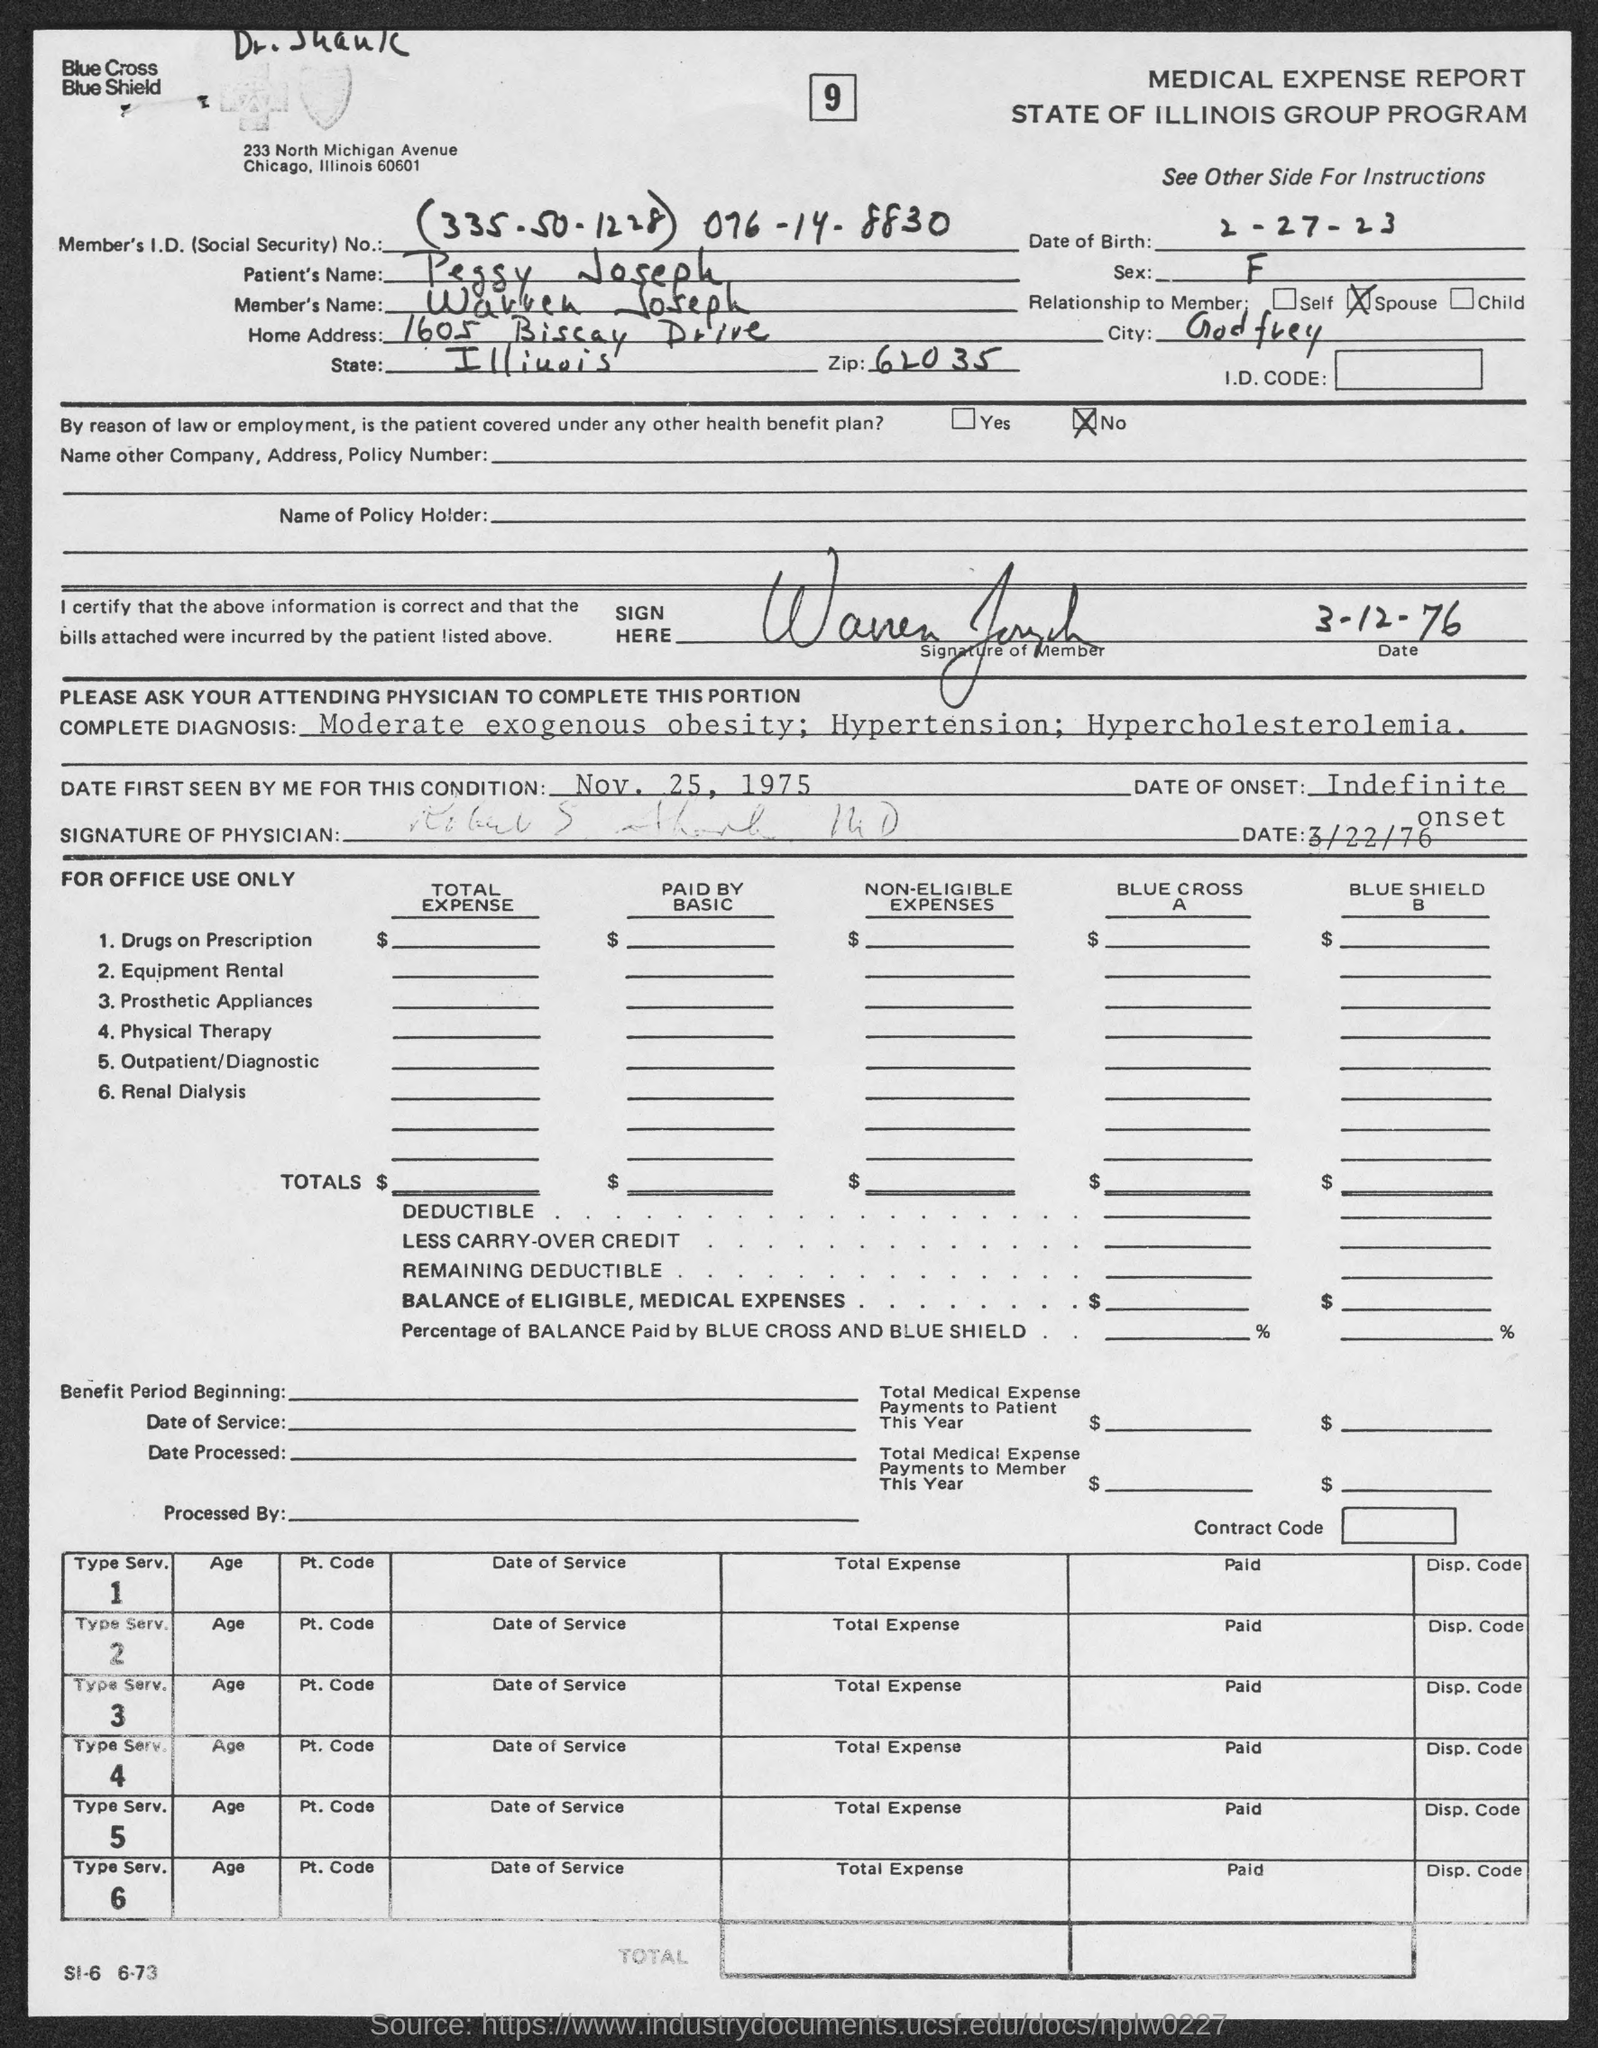List a handful of essential elements in this visual. Onset of the condition is unclear and ongoing. The question "What is the Member's I.D. number (Social Security)?" is asking for the individual's identification number, specifically their Social Security number. The number provided is "335.50.1228" and the individual's name is "076-14-8830. The home address is 1605 Biscay Drive. The member's name is Wavven Joseph. On February 27th, 1923, the date of birth was recorded as 2-27-23. 